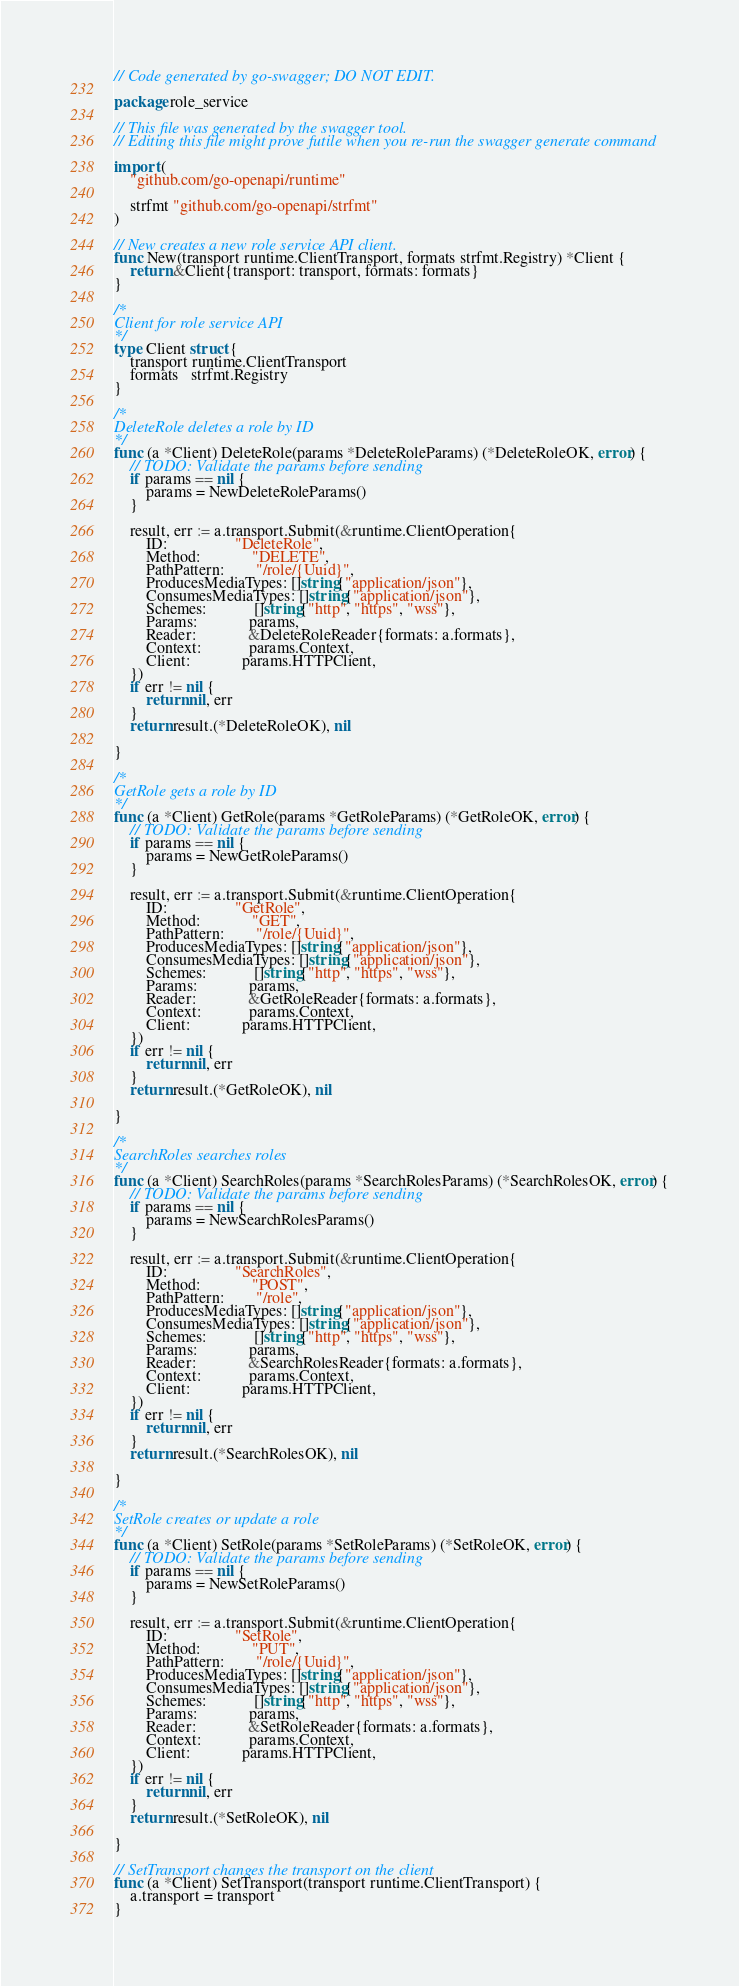Convert code to text. <code><loc_0><loc_0><loc_500><loc_500><_Go_>// Code generated by go-swagger; DO NOT EDIT.

package role_service

// This file was generated by the swagger tool.
// Editing this file might prove futile when you re-run the swagger generate command

import (
	"github.com/go-openapi/runtime"

	strfmt "github.com/go-openapi/strfmt"
)

// New creates a new role service API client.
func New(transport runtime.ClientTransport, formats strfmt.Registry) *Client {
	return &Client{transport: transport, formats: formats}
}

/*
Client for role service API
*/
type Client struct {
	transport runtime.ClientTransport
	formats   strfmt.Registry
}

/*
DeleteRole deletes a role by ID
*/
func (a *Client) DeleteRole(params *DeleteRoleParams) (*DeleteRoleOK, error) {
	// TODO: Validate the params before sending
	if params == nil {
		params = NewDeleteRoleParams()
	}

	result, err := a.transport.Submit(&runtime.ClientOperation{
		ID:                 "DeleteRole",
		Method:             "DELETE",
		PathPattern:        "/role/{Uuid}",
		ProducesMediaTypes: []string{"application/json"},
		ConsumesMediaTypes: []string{"application/json"},
		Schemes:            []string{"http", "https", "wss"},
		Params:             params,
		Reader:             &DeleteRoleReader{formats: a.formats},
		Context:            params.Context,
		Client:             params.HTTPClient,
	})
	if err != nil {
		return nil, err
	}
	return result.(*DeleteRoleOK), nil

}

/*
GetRole gets a role by ID
*/
func (a *Client) GetRole(params *GetRoleParams) (*GetRoleOK, error) {
	// TODO: Validate the params before sending
	if params == nil {
		params = NewGetRoleParams()
	}

	result, err := a.transport.Submit(&runtime.ClientOperation{
		ID:                 "GetRole",
		Method:             "GET",
		PathPattern:        "/role/{Uuid}",
		ProducesMediaTypes: []string{"application/json"},
		ConsumesMediaTypes: []string{"application/json"},
		Schemes:            []string{"http", "https", "wss"},
		Params:             params,
		Reader:             &GetRoleReader{formats: a.formats},
		Context:            params.Context,
		Client:             params.HTTPClient,
	})
	if err != nil {
		return nil, err
	}
	return result.(*GetRoleOK), nil

}

/*
SearchRoles searches roles
*/
func (a *Client) SearchRoles(params *SearchRolesParams) (*SearchRolesOK, error) {
	// TODO: Validate the params before sending
	if params == nil {
		params = NewSearchRolesParams()
	}

	result, err := a.transport.Submit(&runtime.ClientOperation{
		ID:                 "SearchRoles",
		Method:             "POST",
		PathPattern:        "/role",
		ProducesMediaTypes: []string{"application/json"},
		ConsumesMediaTypes: []string{"application/json"},
		Schemes:            []string{"http", "https", "wss"},
		Params:             params,
		Reader:             &SearchRolesReader{formats: a.formats},
		Context:            params.Context,
		Client:             params.HTTPClient,
	})
	if err != nil {
		return nil, err
	}
	return result.(*SearchRolesOK), nil

}

/*
SetRole creates or update a role
*/
func (a *Client) SetRole(params *SetRoleParams) (*SetRoleOK, error) {
	// TODO: Validate the params before sending
	if params == nil {
		params = NewSetRoleParams()
	}

	result, err := a.transport.Submit(&runtime.ClientOperation{
		ID:                 "SetRole",
		Method:             "PUT",
		PathPattern:        "/role/{Uuid}",
		ProducesMediaTypes: []string{"application/json"},
		ConsumesMediaTypes: []string{"application/json"},
		Schemes:            []string{"http", "https", "wss"},
		Params:             params,
		Reader:             &SetRoleReader{formats: a.formats},
		Context:            params.Context,
		Client:             params.HTTPClient,
	})
	if err != nil {
		return nil, err
	}
	return result.(*SetRoleOK), nil

}

// SetTransport changes the transport on the client
func (a *Client) SetTransport(transport runtime.ClientTransport) {
	a.transport = transport
}
</code> 